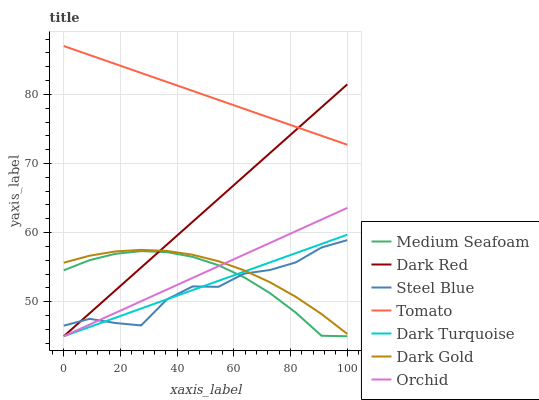Does Steel Blue have the minimum area under the curve?
Answer yes or no. Yes. Does Tomato have the maximum area under the curve?
Answer yes or no. Yes. Does Dark Gold have the minimum area under the curve?
Answer yes or no. No. Does Dark Gold have the maximum area under the curve?
Answer yes or no. No. Is Dark Turquoise the smoothest?
Answer yes or no. Yes. Is Steel Blue the roughest?
Answer yes or no. Yes. Is Dark Gold the smoothest?
Answer yes or no. No. Is Dark Gold the roughest?
Answer yes or no. No. Does Dark Red have the lowest value?
Answer yes or no. Yes. Does Dark Gold have the lowest value?
Answer yes or no. No. Does Tomato have the highest value?
Answer yes or no. Yes. Does Dark Gold have the highest value?
Answer yes or no. No. Is Orchid less than Tomato?
Answer yes or no. Yes. Is Tomato greater than Medium Seafoam?
Answer yes or no. Yes. Does Steel Blue intersect Medium Seafoam?
Answer yes or no. Yes. Is Steel Blue less than Medium Seafoam?
Answer yes or no. No. Is Steel Blue greater than Medium Seafoam?
Answer yes or no. No. Does Orchid intersect Tomato?
Answer yes or no. No. 